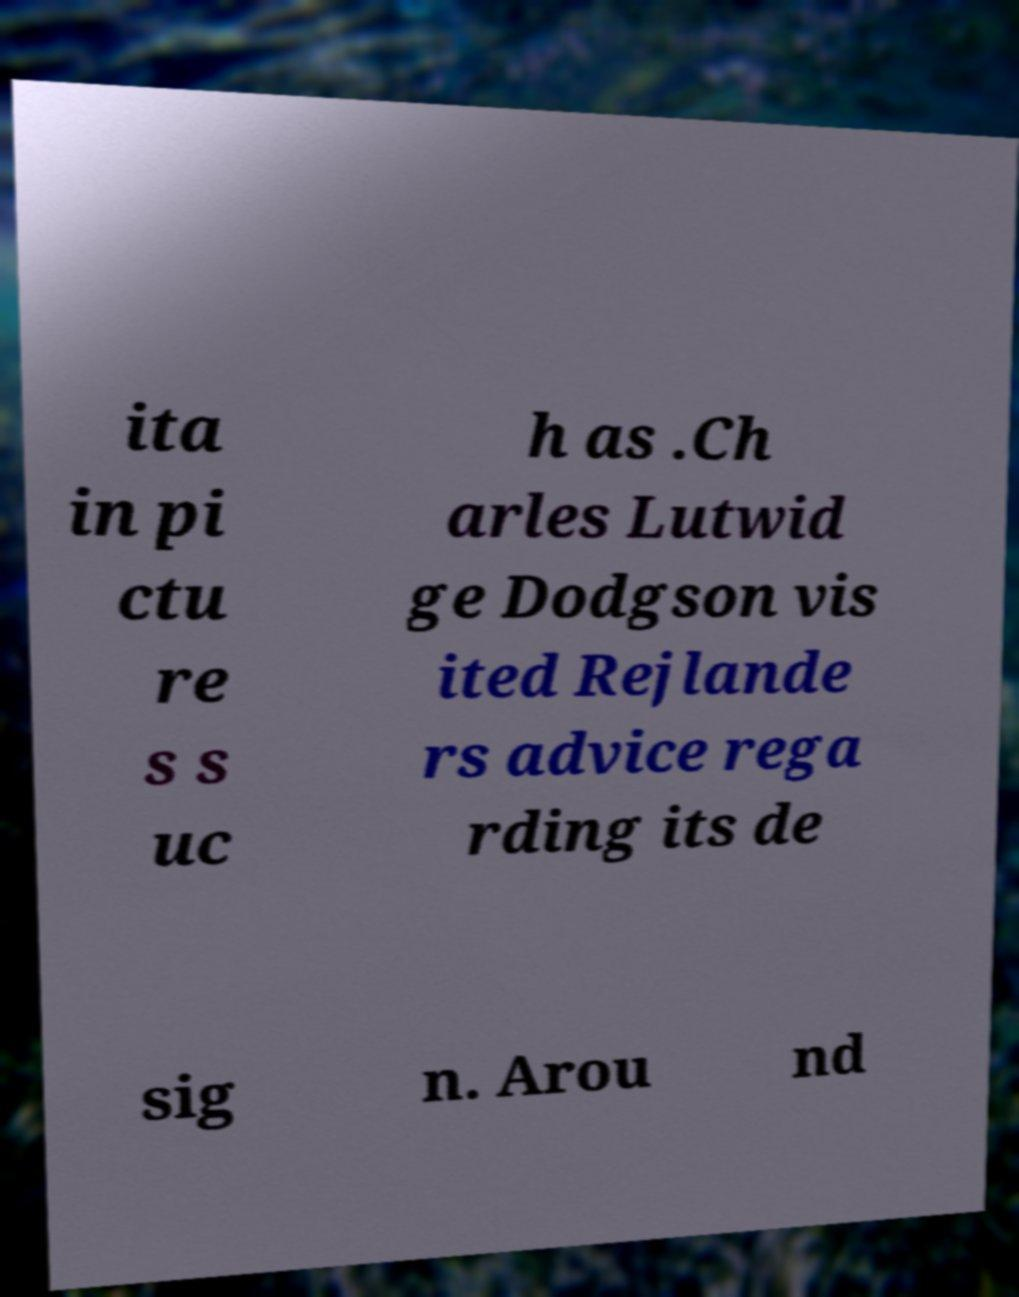Please read and relay the text visible in this image. What does it say? ita in pi ctu re s s uc h as .Ch arles Lutwid ge Dodgson vis ited Rejlande rs advice rega rding its de sig n. Arou nd 